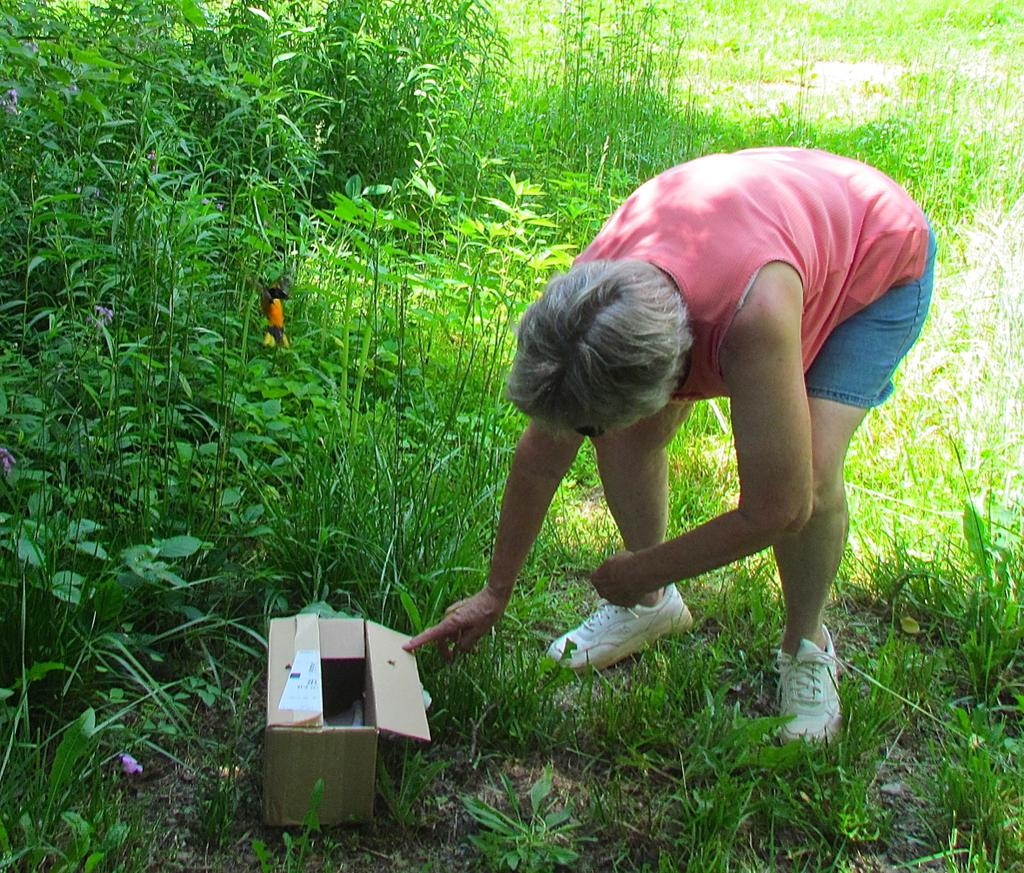Who is in the image? There is a person in the image. What is the person doing in the image? The person is opening a box. Where is the box located in the image? The box is on the ground. What type of environment is depicted in the image? There are many plants and grass in the image, suggesting a natural setting. What type of jam is being spread on the letter in the image? There is no jam or letter present in the image; it features a person opening a box in a natural setting. 